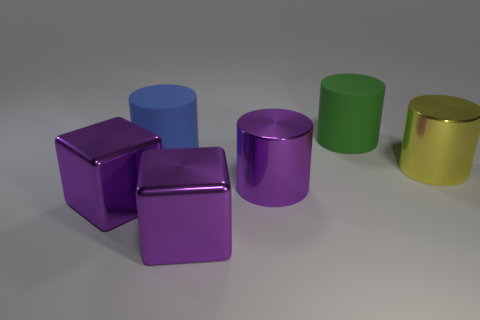Add 1 big blue matte things. How many objects exist? 7 Subtract all cyan cylinders. Subtract all blue spheres. How many cylinders are left? 4 Subtract all cylinders. How many objects are left? 2 Add 1 large metallic cubes. How many large metallic cubes exist? 3 Subtract 0 blue cubes. How many objects are left? 6 Subtract all purple shiny objects. Subtract all large matte objects. How many objects are left? 1 Add 5 large matte objects. How many large matte objects are left? 7 